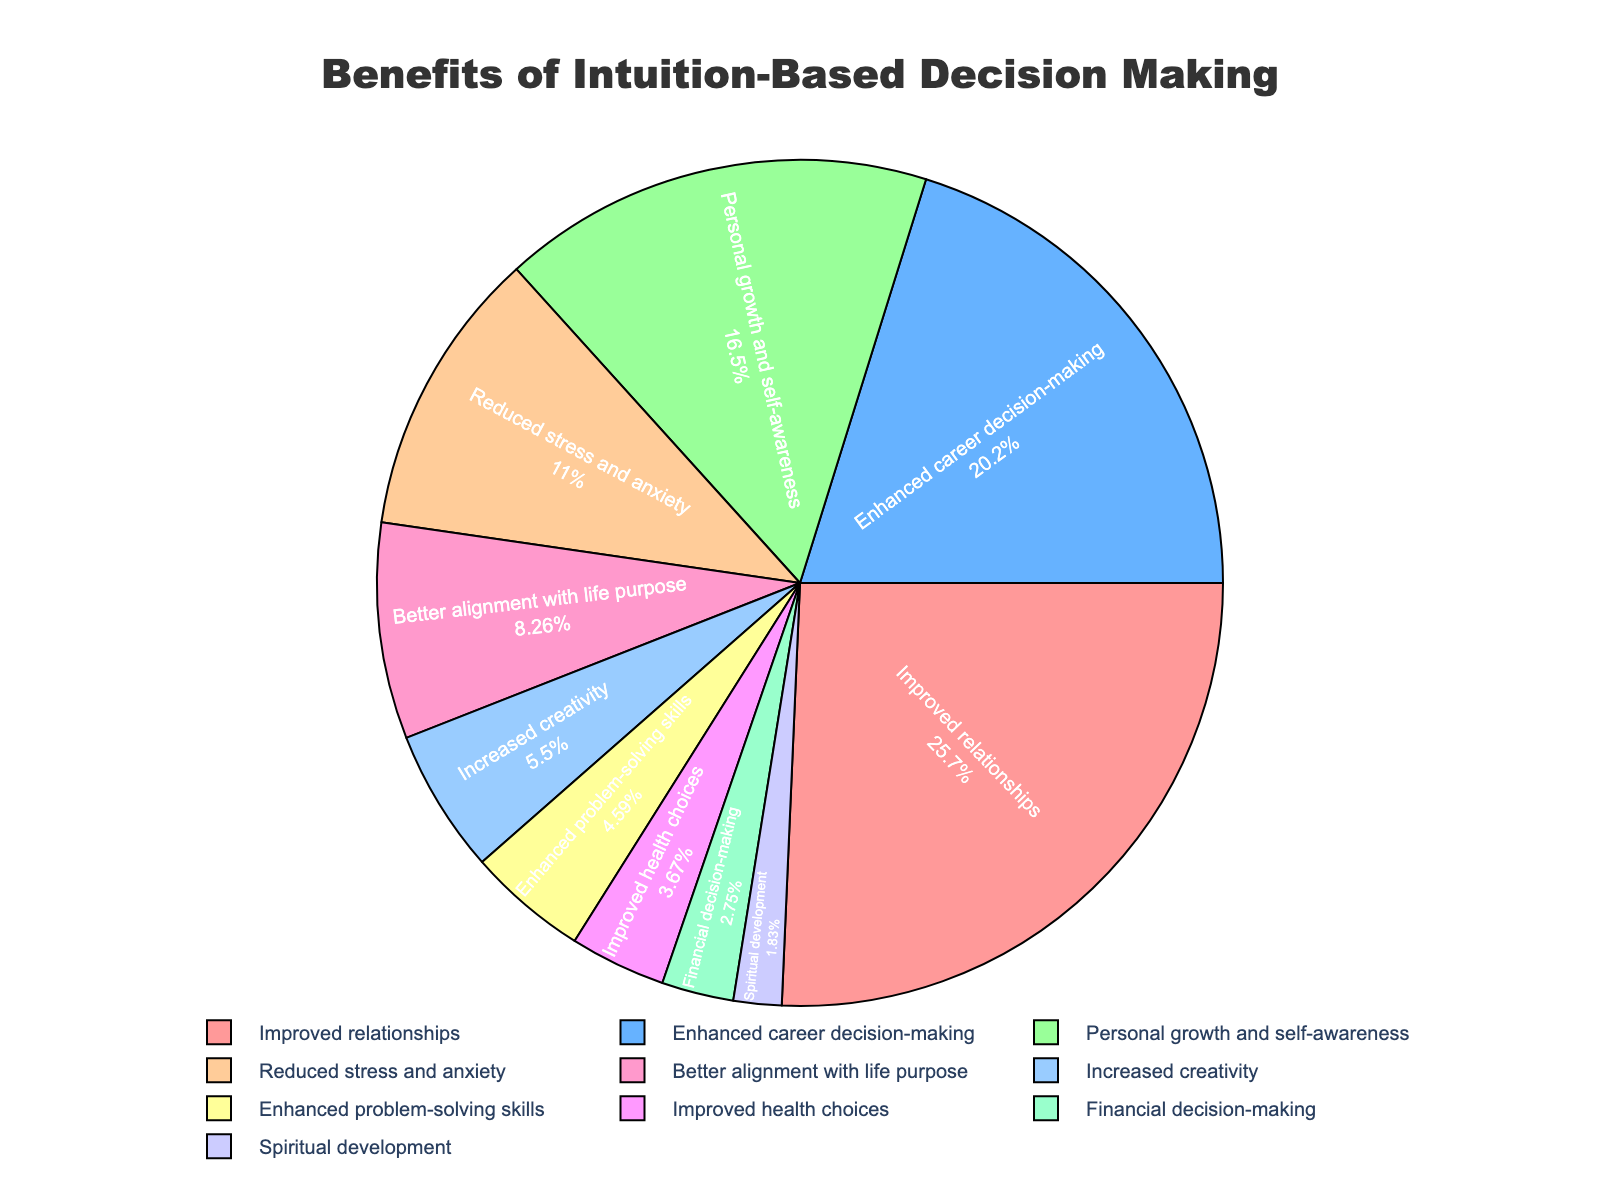What is the percentage of people who reported Improved relationships? First, identify the section of the pie chart labeled "Improved relationships." The pie slice has the associated percentage reported.
Answer: 28% Which category has the smallest percentage and what is that percentage? Locate the smallest slice on the pie chart and find its label. The smallest slice is labeled "Spiritual development" with a percentage of 2%.
Answer: Spiritual development, 2% Is the percentage of Improved relationships greater than the percentage of Financial decision-making? Compare the percentage of Improved relationships (28%) with Financial decision-making (3%). Since 28% is greater than 3%, the answer is yes.
Answer: Yes What is the combined percentage of Reduced stress and anxiety and Better alignment with life purpose? Locate the percentages of Reduced stress and anxiety (12%) and Better alignment with life purpose (9%). Sum these percentages: 12% + 9% = 21%.
Answer: 21% How much greater is Enhanced career decision-making than Increased creativity? Find the percentages for Enhanced career decision-making (22%) and Increased creativity (6%). Subtract the smaller percentage from the larger: 22% - 6% = 16%.
Answer: 16% Which benefits occupy the largest and smallest portions of the pie chart? Identify the largest and smallest slices on the pie chart. The largest is "Improved relationships" at 28%, and the smallest is "Spiritual development" at 2%.
Answer: Improved relationships, Spiritual development Compare the combined percentage of Personal growth and self-awareness and Enhanced problem-solving skills to Improved relationships. Which is greater? Find the percentages for Personal growth and self-awareness (18%) and Enhanced problem-solving skills (5%). Sum these percentages: 18% + 5% = 23%. Compare to Improved relationships (28%). Since 23% is less than 28%, Improved relationships is greater.
Answer: Improved relationships What is the overall percentage of creativity-related benefits (Increased creativity and Enhanced problem-solving skills)? Locate the percentages for Increased creativity (6%) and Enhanced problem-solving skills (5%). Sum these percentages: 6% + 5% = 11%.
Answer: 11% Which slice is orange in color, and what percentage does it represent? Identify the orange-colored slice on the pie chart and find its label and percentage. The orange slice, Enhanced career decision-making, represents 22%.
Answer: Enhanced career decision-making, 22% 